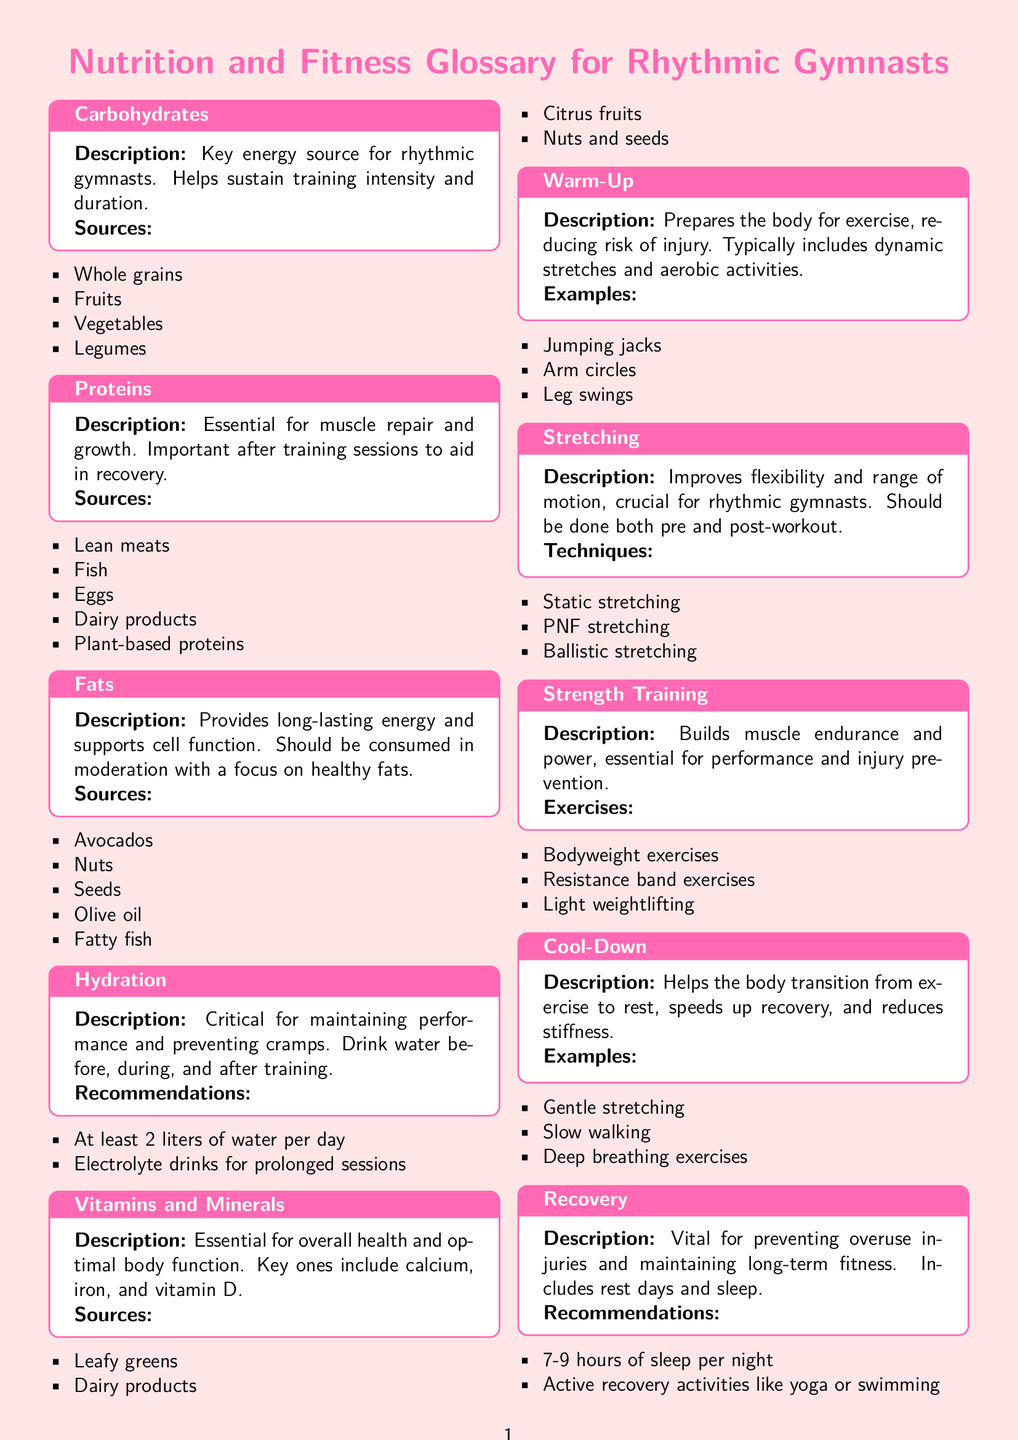What is a key energy source for rhythmic gymnasts? Carbohydrates are identified in the document as a key energy source necessary for sustaining training intensity.
Answer: Carbohydrates What are two examples of healthy fat sources? The document lists avocado and nuts as examples of healthy fat sources.
Answer: Avocados, Nuts How many liters of water should rhythmic gymnasts drink per day? The document recommends at least 2 liters of water per day for hydration.
Answer: 2 liters What is one benefit of the cool-down process? The document states that cool-down helps to transition from exercise to rest, speeding up recovery.
Answer: Speeds up recovery Name one technique for improving flexibility. The document mentions static stretching as a technique for improving flexibility.
Answer: Static stretching What is an essential component of recovery according to the document? The document emphasizes that sleep is vital for recovery, stating 7-9 hours is ideal.
Answer: 7-9 hours What type of exercises does strength training include? The document lists bodyweight exercises as part of strength training exercises.
Answer: Bodyweight exercises What does hydration help prevent? The document indicates that proper hydration is critical for preventing cramps during training.
Answer: Cramps What type of stretching improves range of motion? The document indicates that stretching improves flexibility and range of motion.
Answer: Stretching 